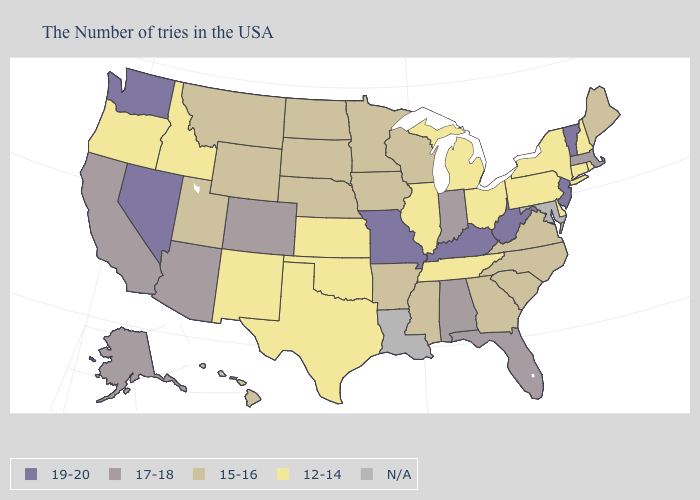What is the lowest value in the South?
Concise answer only. 12-14. Name the states that have a value in the range 19-20?
Give a very brief answer. Vermont, New Jersey, West Virginia, Kentucky, Missouri, Nevada, Washington. Name the states that have a value in the range 17-18?
Short answer required. Massachusetts, Florida, Indiana, Alabama, Colorado, Arizona, California, Alaska. What is the value of New Jersey?
Give a very brief answer. 19-20. Which states have the highest value in the USA?
Quick response, please. Vermont, New Jersey, West Virginia, Kentucky, Missouri, Nevada, Washington. Name the states that have a value in the range 15-16?
Write a very short answer. Maine, Virginia, North Carolina, South Carolina, Georgia, Wisconsin, Mississippi, Arkansas, Minnesota, Iowa, Nebraska, South Dakota, North Dakota, Wyoming, Utah, Montana, Hawaii. Name the states that have a value in the range N/A?
Concise answer only. Maryland, Louisiana. What is the value of Michigan?
Short answer required. 12-14. What is the value of North Carolina?
Short answer required. 15-16. What is the value of Louisiana?
Write a very short answer. N/A. Which states have the lowest value in the USA?
Give a very brief answer. Rhode Island, New Hampshire, Connecticut, New York, Delaware, Pennsylvania, Ohio, Michigan, Tennessee, Illinois, Kansas, Oklahoma, Texas, New Mexico, Idaho, Oregon. What is the value of Alaska?
Give a very brief answer. 17-18. Does the map have missing data?
Concise answer only. Yes. Name the states that have a value in the range 12-14?
Give a very brief answer. Rhode Island, New Hampshire, Connecticut, New York, Delaware, Pennsylvania, Ohio, Michigan, Tennessee, Illinois, Kansas, Oklahoma, Texas, New Mexico, Idaho, Oregon. What is the highest value in states that border North Carolina?
Write a very short answer. 15-16. 